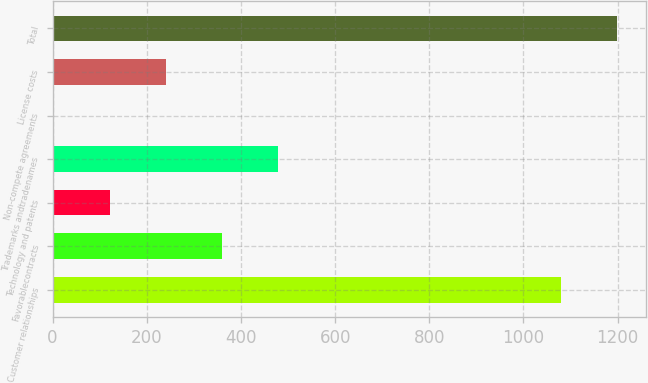Convert chart to OTSL. <chart><loc_0><loc_0><loc_500><loc_500><bar_chart><fcel>Customer relationships<fcel>Favorablecontracts<fcel>Technology and patents<fcel>Trademarks andtradenames<fcel>Non-compete agreements<fcel>License costs<fcel>Total<nl><fcel>1079.8<fcel>360.08<fcel>121.16<fcel>479.54<fcel>1.7<fcel>240.62<fcel>1199.26<nl></chart> 